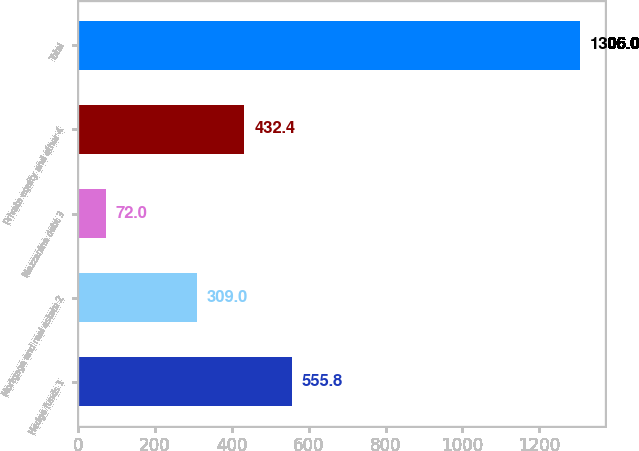Convert chart. <chart><loc_0><loc_0><loc_500><loc_500><bar_chart><fcel>Hedge funds 1<fcel>Mortgage and real estate 2<fcel>Mezzanine debt 3<fcel>Private equity and other 4<fcel>Total<nl><fcel>555.8<fcel>309<fcel>72<fcel>432.4<fcel>1306<nl></chart> 